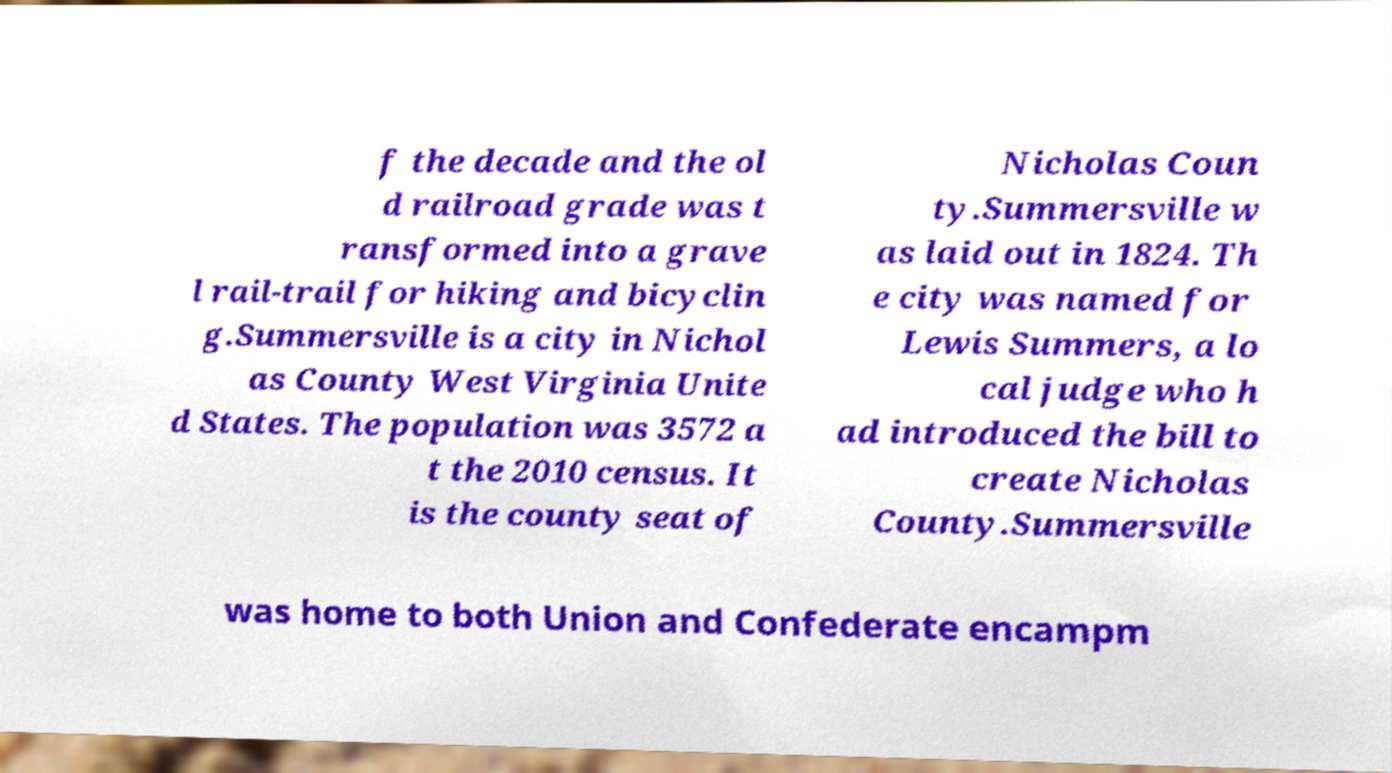Please read and relay the text visible in this image. What does it say? f the decade and the ol d railroad grade was t ransformed into a grave l rail-trail for hiking and bicyclin g.Summersville is a city in Nichol as County West Virginia Unite d States. The population was 3572 a t the 2010 census. It is the county seat of Nicholas Coun ty.Summersville w as laid out in 1824. Th e city was named for Lewis Summers, a lo cal judge who h ad introduced the bill to create Nicholas County.Summersville was home to both Union and Confederate encampm 